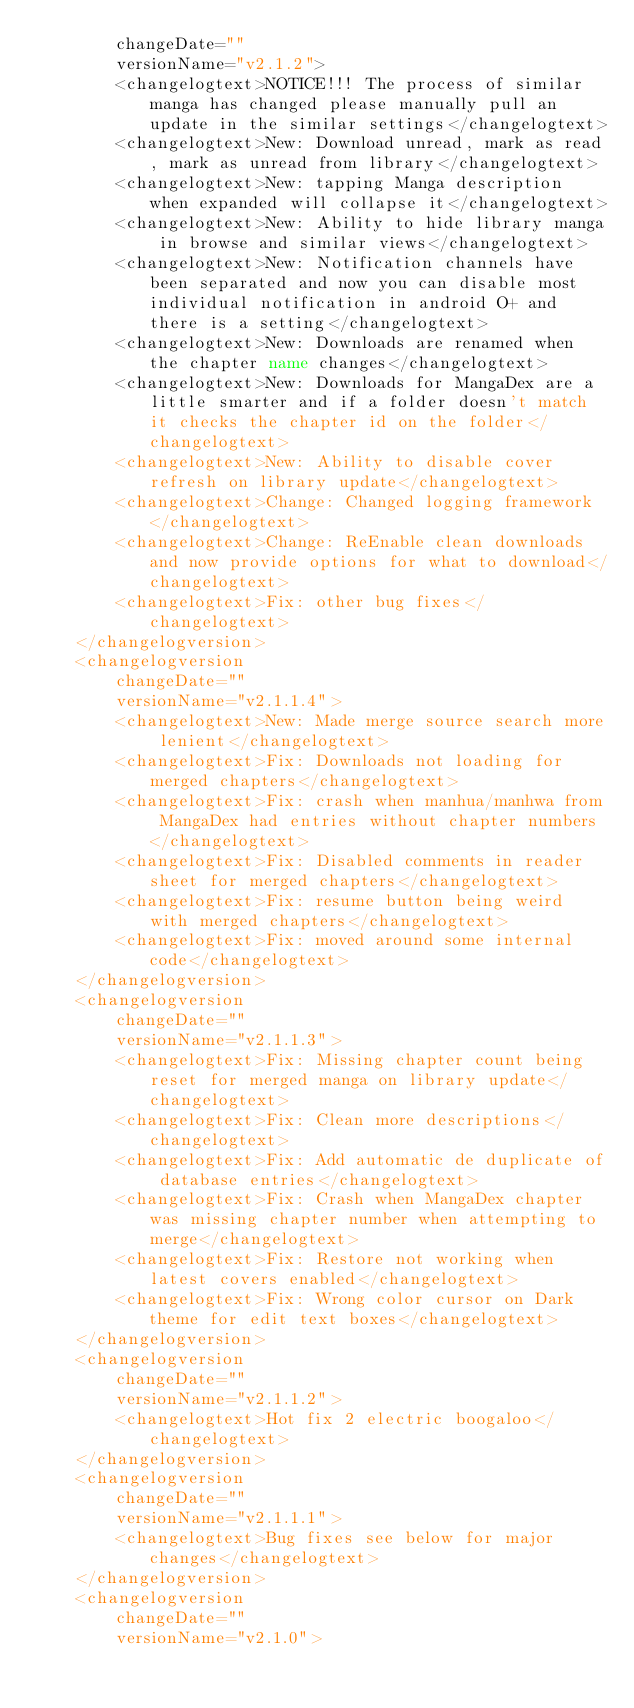<code> <loc_0><loc_0><loc_500><loc_500><_XML_>        changeDate=""
        versionName="v2.1.2">
        <changelogtext>NOTICE!!! The process of similar manga has changed please manually pull an update in the similar settings</changelogtext>
        <changelogtext>New: Download unread, mark as read, mark as unread from library</changelogtext>
        <changelogtext>New: tapping Manga description when expanded will collapse it</changelogtext>
        <changelogtext>New: Ability to hide library manga in browse and similar views</changelogtext>
        <changelogtext>New: Notification channels have been separated and now you can disable most individual notification in android O+ and there is a setting</changelogtext>
        <changelogtext>New: Downloads are renamed when the chapter name changes</changelogtext>
        <changelogtext>New: Downloads for MangaDex are a little smarter and if a folder doesn't match it checks the chapter id on the folder</changelogtext>
        <changelogtext>New: Ability to disable cover refresh on library update</changelogtext>
        <changelogtext>Change: Changed logging framework</changelogtext>
        <changelogtext>Change: ReEnable clean downloads and now provide options for what to download</changelogtext>
        <changelogtext>Fix: other bug fixes</changelogtext>
    </changelogversion>
    <changelogversion
        changeDate=""
        versionName="v2.1.1.4">
        <changelogtext>New: Made merge source search more lenient</changelogtext>
        <changelogtext>Fix: Downloads not loading for merged chapters</changelogtext>
        <changelogtext>Fix: crash when manhua/manhwa from MangaDex had entries without chapter numbers</changelogtext>
        <changelogtext>Fix: Disabled comments in reader sheet for merged chapters</changelogtext>
        <changelogtext>Fix: resume button being weird with merged chapters</changelogtext>
        <changelogtext>Fix: moved around some internal code</changelogtext>
    </changelogversion>
    <changelogversion
        changeDate=""
        versionName="v2.1.1.3">
        <changelogtext>Fix: Missing chapter count being reset for merged manga on library update</changelogtext>
        <changelogtext>Fix: Clean more descriptions</changelogtext>
        <changelogtext>Fix: Add automatic de duplicate of database entries</changelogtext>
        <changelogtext>Fix: Crash when MangaDex chapter was missing chapter number when attempting to merge</changelogtext>
        <changelogtext>Fix: Restore not working when latest covers enabled</changelogtext>
        <changelogtext>Fix: Wrong color cursor on Dark theme for edit text boxes</changelogtext>
    </changelogversion>
    <changelogversion
        changeDate=""
        versionName="v2.1.1.2">
        <changelogtext>Hot fix 2 electric boogaloo</changelogtext>
    </changelogversion>
    <changelogversion
        changeDate=""
        versionName="v2.1.1.1">
        <changelogtext>Bug fixes see below for major changes</changelogtext>
    </changelogversion>
    <changelogversion
        changeDate=""
        versionName="v2.1.0"></code> 